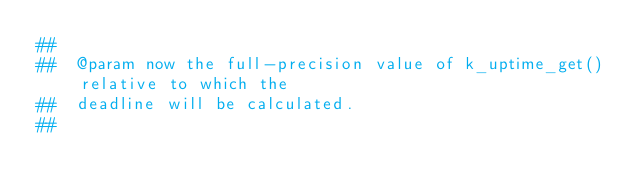<code> <loc_0><loc_0><loc_500><loc_500><_Nim_>##
##  @param now the full-precision value of k_uptime_get() relative to which the
##  deadline will be calculated.
##</code> 